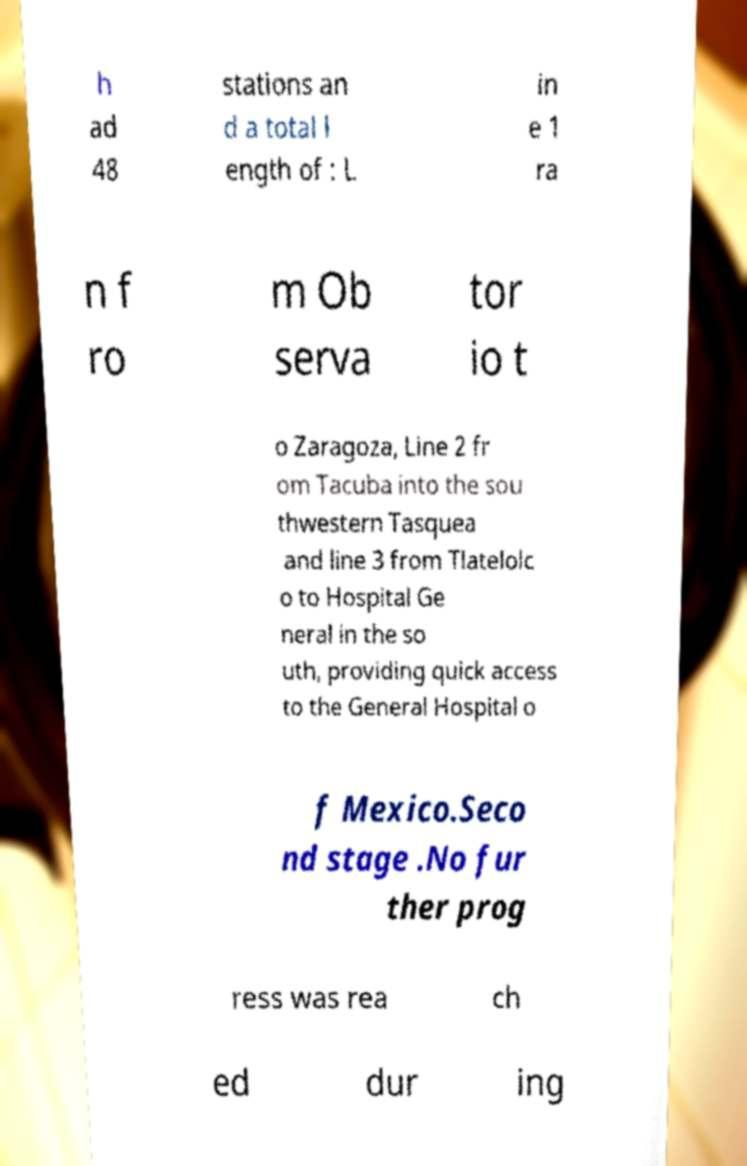Could you assist in decoding the text presented in this image and type it out clearly? h ad 48 stations an d a total l ength of : L in e 1 ra n f ro m Ob serva tor io t o Zaragoza, Line 2 fr om Tacuba into the sou thwestern Tasquea and line 3 from Tlatelolc o to Hospital Ge neral in the so uth, providing quick access to the General Hospital o f Mexico.Seco nd stage .No fur ther prog ress was rea ch ed dur ing 